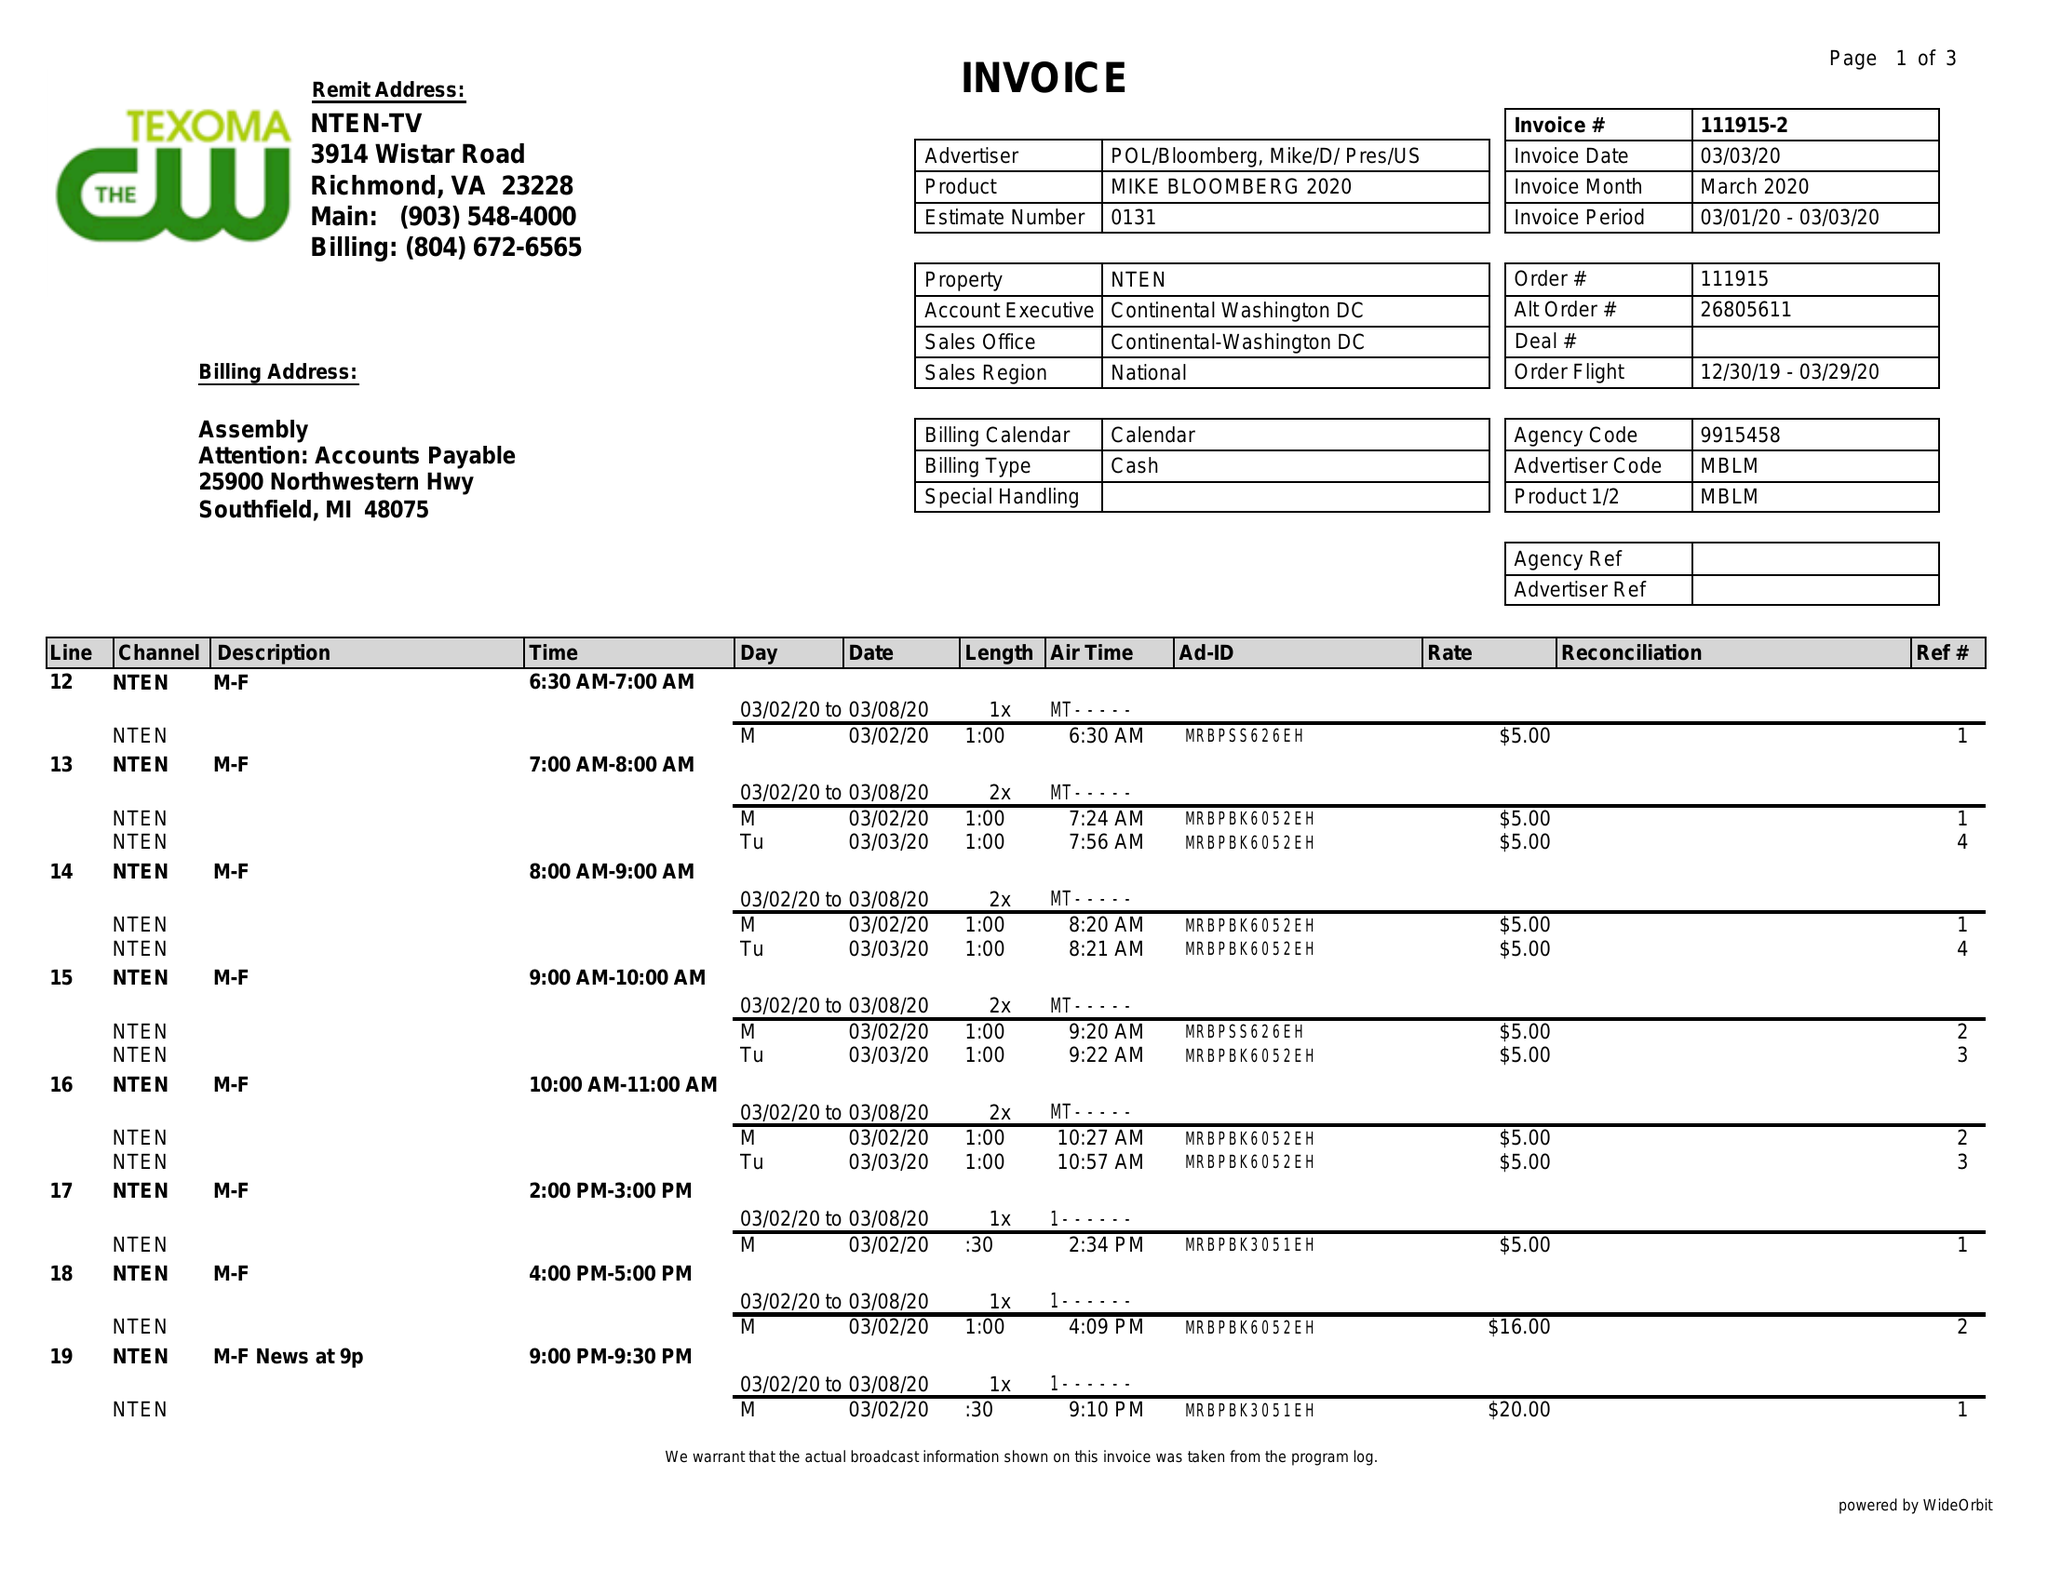What is the value for the flight_to?
Answer the question using a single word or phrase. 03/29/20 